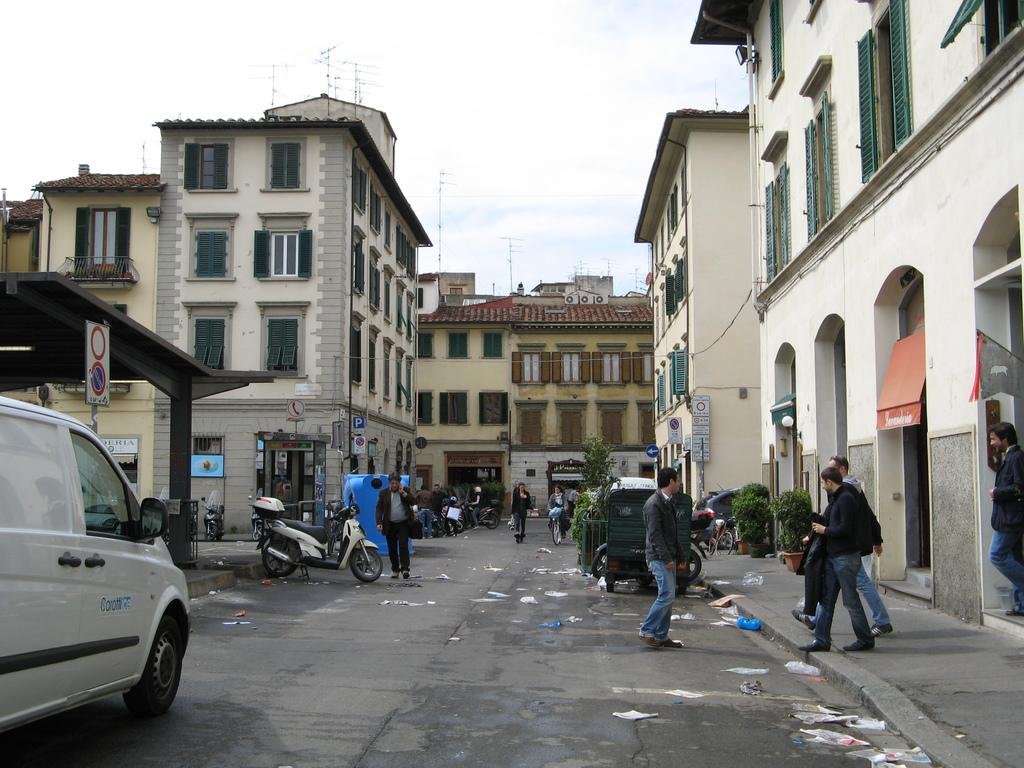What is happening on the road in the image? There are persons on the road in the image. What else can be seen in the image besides the persons on the road? There are vehicles in the image. What type of structures are present on either side of the road? There are buildings on either side of the road. What type of drum can be seen in the image? There is no drum present in the image. What scientific experiment is being conducted in the image? There is no scientific experiment depicted in the image. 